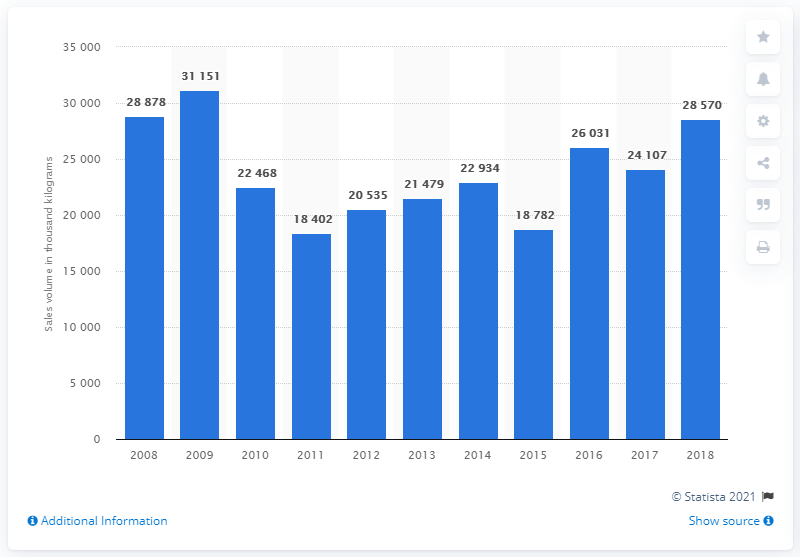What was the sales volume of mixed fruit and nuts in 2018? In 2018, the sales volume of mixed fruit and nuts reached 28,878 thousand kilograms, reflecting a slight decrease compared to the previous year, which was 28,570 thousand kilograms. 